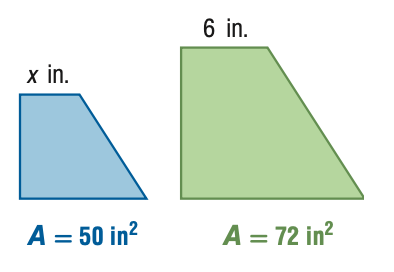Answer the mathemtical geometry problem and directly provide the correct option letter.
Question: For the pair of similar figures, use the given areas to find the scale factor of the blue to the green figure.
Choices: A: \frac { 25 } { 36 } B: \frac { 5 } { 6 } C: \frac { 6 } { 5 } D: \frac { 36 } { 25 } B 